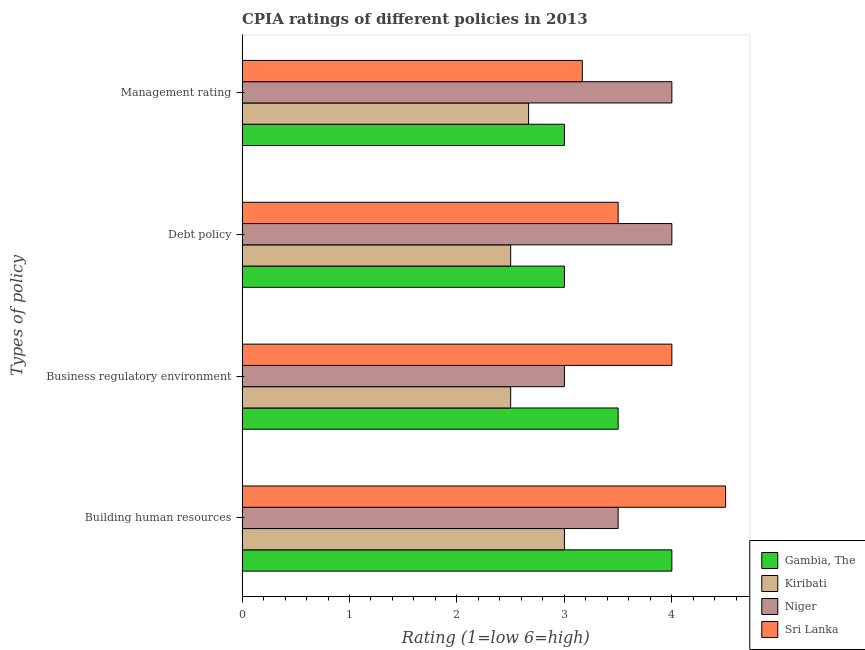How many different coloured bars are there?
Provide a short and direct response. 4. Are the number of bars per tick equal to the number of legend labels?
Provide a succinct answer. Yes. How many bars are there on the 2nd tick from the top?
Provide a succinct answer. 4. How many bars are there on the 3rd tick from the bottom?
Provide a short and direct response. 4. What is the label of the 2nd group of bars from the top?
Keep it short and to the point. Debt policy. What is the cpia rating of building human resources in Sri Lanka?
Your answer should be compact. 4.5. Across all countries, what is the minimum cpia rating of management?
Provide a succinct answer. 2.67. In which country was the cpia rating of business regulatory environment maximum?
Your answer should be very brief. Sri Lanka. In which country was the cpia rating of management minimum?
Ensure brevity in your answer.  Kiribati. What is the total cpia rating of building human resources in the graph?
Give a very brief answer. 15. What is the difference between the cpia rating of building human resources in Gambia, The and that in Kiribati?
Keep it short and to the point. 1. What is the difference between the cpia rating of building human resources in Kiribati and the cpia rating of debt policy in Gambia, The?
Offer a very short reply. 0. In how many countries, is the cpia rating of management greater than 3.2 ?
Your response must be concise. 1. What is the ratio of the cpia rating of management in Kiribati to that in Niger?
Provide a succinct answer. 0.67. Is the cpia rating of management in Sri Lanka less than that in Gambia, The?
Offer a terse response. No. Is the difference between the cpia rating of building human resources in Sri Lanka and Niger greater than the difference between the cpia rating of business regulatory environment in Sri Lanka and Niger?
Your response must be concise. No. What is the difference between the highest and the second highest cpia rating of building human resources?
Provide a succinct answer. 0.5. What is the difference between the highest and the lowest cpia rating of building human resources?
Ensure brevity in your answer.  1.5. In how many countries, is the cpia rating of debt policy greater than the average cpia rating of debt policy taken over all countries?
Provide a succinct answer. 2. Is the sum of the cpia rating of debt policy in Kiribati and Gambia, The greater than the maximum cpia rating of management across all countries?
Offer a terse response. Yes. Is it the case that in every country, the sum of the cpia rating of business regulatory environment and cpia rating of building human resources is greater than the sum of cpia rating of debt policy and cpia rating of management?
Give a very brief answer. No. What does the 2nd bar from the top in Building human resources represents?
Make the answer very short. Niger. What does the 2nd bar from the bottom in Business regulatory environment represents?
Keep it short and to the point. Kiribati. Is it the case that in every country, the sum of the cpia rating of building human resources and cpia rating of business regulatory environment is greater than the cpia rating of debt policy?
Give a very brief answer. Yes. How many bars are there?
Offer a very short reply. 16. How many countries are there in the graph?
Your answer should be very brief. 4. Are the values on the major ticks of X-axis written in scientific E-notation?
Keep it short and to the point. No. Does the graph contain grids?
Your response must be concise. No. Where does the legend appear in the graph?
Offer a very short reply. Bottom right. What is the title of the graph?
Make the answer very short. CPIA ratings of different policies in 2013. What is the label or title of the Y-axis?
Make the answer very short. Types of policy. What is the Rating (1=low 6=high) of Gambia, The in Building human resources?
Provide a succinct answer. 4. What is the Rating (1=low 6=high) of Niger in Building human resources?
Ensure brevity in your answer.  3.5. What is the Rating (1=low 6=high) in Sri Lanka in Building human resources?
Your response must be concise. 4.5. What is the Rating (1=low 6=high) of Gambia, The in Business regulatory environment?
Your answer should be compact. 3.5. What is the Rating (1=low 6=high) of Kiribati in Business regulatory environment?
Give a very brief answer. 2.5. What is the Rating (1=low 6=high) in Niger in Business regulatory environment?
Ensure brevity in your answer.  3. What is the Rating (1=low 6=high) in Sri Lanka in Business regulatory environment?
Offer a very short reply. 4. What is the Rating (1=low 6=high) of Niger in Debt policy?
Provide a short and direct response. 4. What is the Rating (1=low 6=high) in Sri Lanka in Debt policy?
Your response must be concise. 3.5. What is the Rating (1=low 6=high) in Kiribati in Management rating?
Offer a terse response. 2.67. What is the Rating (1=low 6=high) of Niger in Management rating?
Your answer should be compact. 4. What is the Rating (1=low 6=high) of Sri Lanka in Management rating?
Offer a very short reply. 3.17. Across all Types of policy, what is the maximum Rating (1=low 6=high) of Gambia, The?
Keep it short and to the point. 4. Across all Types of policy, what is the maximum Rating (1=low 6=high) in Kiribati?
Ensure brevity in your answer.  3. Across all Types of policy, what is the maximum Rating (1=low 6=high) of Niger?
Your answer should be compact. 4. Across all Types of policy, what is the maximum Rating (1=low 6=high) of Sri Lanka?
Offer a terse response. 4.5. Across all Types of policy, what is the minimum Rating (1=low 6=high) in Niger?
Give a very brief answer. 3. Across all Types of policy, what is the minimum Rating (1=low 6=high) in Sri Lanka?
Offer a very short reply. 3.17. What is the total Rating (1=low 6=high) in Kiribati in the graph?
Offer a very short reply. 10.67. What is the total Rating (1=low 6=high) in Sri Lanka in the graph?
Keep it short and to the point. 15.17. What is the difference between the Rating (1=low 6=high) of Niger in Building human resources and that in Business regulatory environment?
Your answer should be very brief. 0.5. What is the difference between the Rating (1=low 6=high) in Niger in Building human resources and that in Debt policy?
Your response must be concise. -0.5. What is the difference between the Rating (1=low 6=high) of Sri Lanka in Building human resources and that in Debt policy?
Keep it short and to the point. 1. What is the difference between the Rating (1=low 6=high) of Niger in Business regulatory environment and that in Debt policy?
Your answer should be very brief. -1. What is the difference between the Rating (1=low 6=high) of Sri Lanka in Business regulatory environment and that in Debt policy?
Ensure brevity in your answer.  0.5. What is the difference between the Rating (1=low 6=high) in Kiribati in Business regulatory environment and that in Management rating?
Offer a very short reply. -0.17. What is the difference between the Rating (1=low 6=high) of Niger in Business regulatory environment and that in Management rating?
Provide a succinct answer. -1. What is the difference between the Rating (1=low 6=high) of Kiribati in Debt policy and that in Management rating?
Provide a short and direct response. -0.17. What is the difference between the Rating (1=low 6=high) in Niger in Debt policy and that in Management rating?
Give a very brief answer. 0. What is the difference between the Rating (1=low 6=high) of Sri Lanka in Debt policy and that in Management rating?
Give a very brief answer. 0.33. What is the difference between the Rating (1=low 6=high) of Gambia, The in Building human resources and the Rating (1=low 6=high) of Kiribati in Business regulatory environment?
Your response must be concise. 1.5. What is the difference between the Rating (1=low 6=high) of Gambia, The in Building human resources and the Rating (1=low 6=high) of Niger in Business regulatory environment?
Ensure brevity in your answer.  1. What is the difference between the Rating (1=low 6=high) in Gambia, The in Building human resources and the Rating (1=low 6=high) in Sri Lanka in Business regulatory environment?
Offer a very short reply. 0. What is the difference between the Rating (1=low 6=high) in Kiribati in Building human resources and the Rating (1=low 6=high) in Sri Lanka in Business regulatory environment?
Your answer should be very brief. -1. What is the difference between the Rating (1=low 6=high) in Niger in Building human resources and the Rating (1=low 6=high) in Sri Lanka in Business regulatory environment?
Your response must be concise. -0.5. What is the difference between the Rating (1=low 6=high) of Gambia, The in Building human resources and the Rating (1=low 6=high) of Kiribati in Debt policy?
Make the answer very short. 1.5. What is the difference between the Rating (1=low 6=high) in Gambia, The in Building human resources and the Rating (1=low 6=high) in Niger in Debt policy?
Offer a very short reply. 0. What is the difference between the Rating (1=low 6=high) in Gambia, The in Building human resources and the Rating (1=low 6=high) in Sri Lanka in Debt policy?
Offer a very short reply. 0.5. What is the difference between the Rating (1=low 6=high) in Kiribati in Building human resources and the Rating (1=low 6=high) in Sri Lanka in Debt policy?
Offer a terse response. -0.5. What is the difference between the Rating (1=low 6=high) of Gambia, The in Building human resources and the Rating (1=low 6=high) of Kiribati in Management rating?
Offer a very short reply. 1.33. What is the difference between the Rating (1=low 6=high) of Gambia, The in Building human resources and the Rating (1=low 6=high) of Niger in Management rating?
Your answer should be compact. 0. What is the difference between the Rating (1=low 6=high) in Kiribati in Building human resources and the Rating (1=low 6=high) in Niger in Management rating?
Keep it short and to the point. -1. What is the difference between the Rating (1=low 6=high) in Kiribati in Building human resources and the Rating (1=low 6=high) in Sri Lanka in Management rating?
Offer a very short reply. -0.17. What is the difference between the Rating (1=low 6=high) of Niger in Building human resources and the Rating (1=low 6=high) of Sri Lanka in Management rating?
Provide a succinct answer. 0.33. What is the difference between the Rating (1=low 6=high) of Gambia, The in Business regulatory environment and the Rating (1=low 6=high) of Sri Lanka in Debt policy?
Make the answer very short. 0. What is the difference between the Rating (1=low 6=high) of Gambia, The in Business regulatory environment and the Rating (1=low 6=high) of Niger in Management rating?
Offer a very short reply. -0.5. What is the difference between the Rating (1=low 6=high) in Kiribati in Business regulatory environment and the Rating (1=low 6=high) in Niger in Management rating?
Provide a short and direct response. -1.5. What is the difference between the Rating (1=low 6=high) in Kiribati in Business regulatory environment and the Rating (1=low 6=high) in Sri Lanka in Management rating?
Your answer should be compact. -0.67. What is the difference between the Rating (1=low 6=high) of Niger in Business regulatory environment and the Rating (1=low 6=high) of Sri Lanka in Management rating?
Provide a succinct answer. -0.17. What is the average Rating (1=low 6=high) of Gambia, The per Types of policy?
Your response must be concise. 3.38. What is the average Rating (1=low 6=high) in Kiribati per Types of policy?
Your answer should be very brief. 2.67. What is the average Rating (1=low 6=high) in Niger per Types of policy?
Provide a short and direct response. 3.62. What is the average Rating (1=low 6=high) in Sri Lanka per Types of policy?
Offer a very short reply. 3.79. What is the difference between the Rating (1=low 6=high) of Kiribati and Rating (1=low 6=high) of Niger in Building human resources?
Offer a very short reply. -0.5. What is the difference between the Rating (1=low 6=high) of Kiribati and Rating (1=low 6=high) of Sri Lanka in Building human resources?
Your answer should be very brief. -1.5. What is the difference between the Rating (1=low 6=high) in Niger and Rating (1=low 6=high) in Sri Lanka in Building human resources?
Provide a succinct answer. -1. What is the difference between the Rating (1=low 6=high) of Gambia, The and Rating (1=low 6=high) of Kiribati in Business regulatory environment?
Provide a succinct answer. 1. What is the difference between the Rating (1=low 6=high) in Gambia, The and Rating (1=low 6=high) in Niger in Business regulatory environment?
Ensure brevity in your answer.  0.5. What is the difference between the Rating (1=low 6=high) of Kiribati and Rating (1=low 6=high) of Sri Lanka in Business regulatory environment?
Offer a terse response. -1.5. What is the difference between the Rating (1=low 6=high) of Niger and Rating (1=low 6=high) of Sri Lanka in Debt policy?
Provide a short and direct response. 0.5. What is the difference between the Rating (1=low 6=high) in Gambia, The and Rating (1=low 6=high) in Kiribati in Management rating?
Your response must be concise. 0.33. What is the difference between the Rating (1=low 6=high) in Gambia, The and Rating (1=low 6=high) in Sri Lanka in Management rating?
Your response must be concise. -0.17. What is the difference between the Rating (1=low 6=high) in Kiribati and Rating (1=low 6=high) in Niger in Management rating?
Your response must be concise. -1.33. What is the difference between the Rating (1=low 6=high) of Niger and Rating (1=low 6=high) of Sri Lanka in Management rating?
Give a very brief answer. 0.83. What is the ratio of the Rating (1=low 6=high) in Kiribati in Building human resources to that in Business regulatory environment?
Your answer should be compact. 1.2. What is the ratio of the Rating (1=low 6=high) in Niger in Building human resources to that in Business regulatory environment?
Offer a very short reply. 1.17. What is the ratio of the Rating (1=low 6=high) in Sri Lanka in Building human resources to that in Business regulatory environment?
Offer a very short reply. 1.12. What is the ratio of the Rating (1=low 6=high) of Gambia, The in Building human resources to that in Debt policy?
Give a very brief answer. 1.33. What is the ratio of the Rating (1=low 6=high) of Kiribati in Building human resources to that in Debt policy?
Give a very brief answer. 1.2. What is the ratio of the Rating (1=low 6=high) in Kiribati in Building human resources to that in Management rating?
Provide a short and direct response. 1.12. What is the ratio of the Rating (1=low 6=high) in Sri Lanka in Building human resources to that in Management rating?
Ensure brevity in your answer.  1.42. What is the ratio of the Rating (1=low 6=high) in Kiribati in Business regulatory environment to that in Debt policy?
Offer a very short reply. 1. What is the ratio of the Rating (1=low 6=high) in Niger in Business regulatory environment to that in Debt policy?
Keep it short and to the point. 0.75. What is the ratio of the Rating (1=low 6=high) in Sri Lanka in Business regulatory environment to that in Debt policy?
Make the answer very short. 1.14. What is the ratio of the Rating (1=low 6=high) in Niger in Business regulatory environment to that in Management rating?
Ensure brevity in your answer.  0.75. What is the ratio of the Rating (1=low 6=high) in Sri Lanka in Business regulatory environment to that in Management rating?
Offer a very short reply. 1.26. What is the ratio of the Rating (1=low 6=high) of Gambia, The in Debt policy to that in Management rating?
Your answer should be very brief. 1. What is the ratio of the Rating (1=low 6=high) of Niger in Debt policy to that in Management rating?
Your answer should be very brief. 1. What is the ratio of the Rating (1=low 6=high) of Sri Lanka in Debt policy to that in Management rating?
Give a very brief answer. 1.11. What is the difference between the highest and the second highest Rating (1=low 6=high) in Sri Lanka?
Give a very brief answer. 0.5. What is the difference between the highest and the lowest Rating (1=low 6=high) of Kiribati?
Offer a very short reply. 0.5. What is the difference between the highest and the lowest Rating (1=low 6=high) in Sri Lanka?
Your answer should be compact. 1.33. 